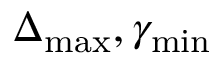<formula> <loc_0><loc_0><loc_500><loc_500>\Delta _ { \max } , \gamma _ { \min }</formula> 